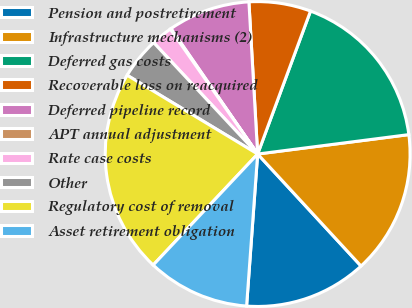Convert chart. <chart><loc_0><loc_0><loc_500><loc_500><pie_chart><fcel>Pension and postretirement<fcel>Infrastructure mechanisms (2)<fcel>Deferred gas costs<fcel>Recoverable loss on reacquired<fcel>Deferred pipeline record<fcel>APT annual adjustment<fcel>Rate case costs<fcel>Other<fcel>Regulatory cost of removal<fcel>Asset retirement obligation<nl><fcel>13.02%<fcel>15.17%<fcel>17.33%<fcel>6.55%<fcel>8.71%<fcel>0.09%<fcel>2.24%<fcel>4.4%<fcel>21.63%<fcel>10.86%<nl></chart> 